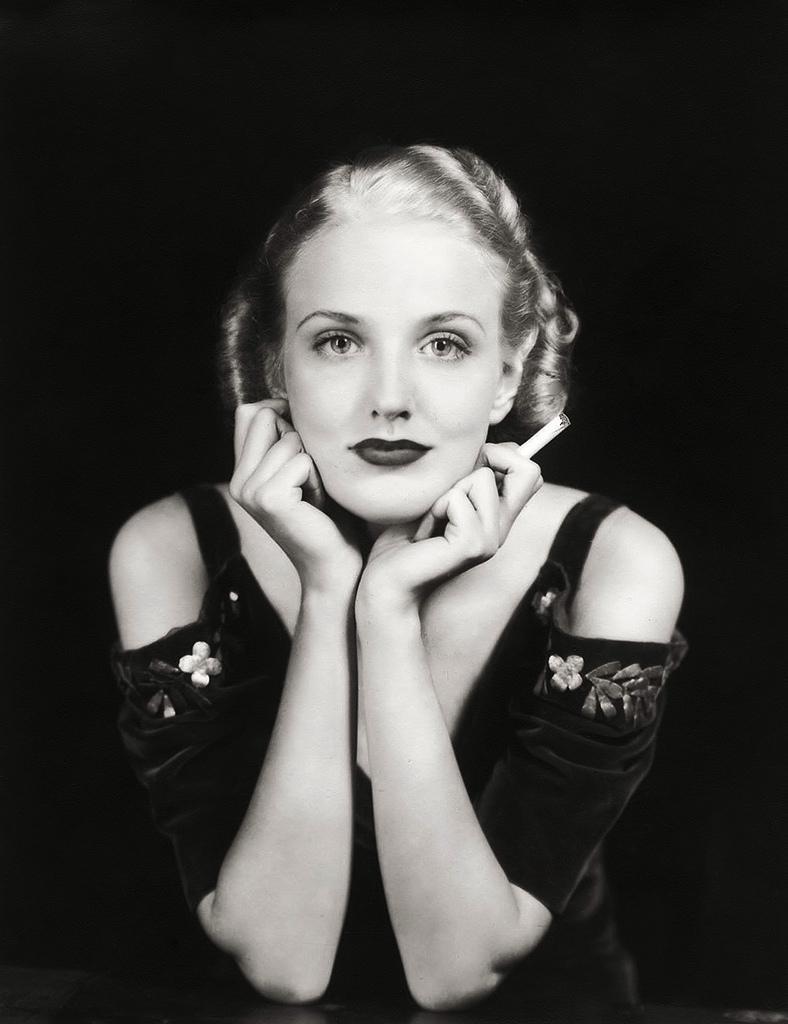Can you describe this image briefly? This is a black and white image and here we can see a lady. 